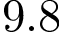Convert formula to latex. <formula><loc_0><loc_0><loc_500><loc_500>9 . 8</formula> 